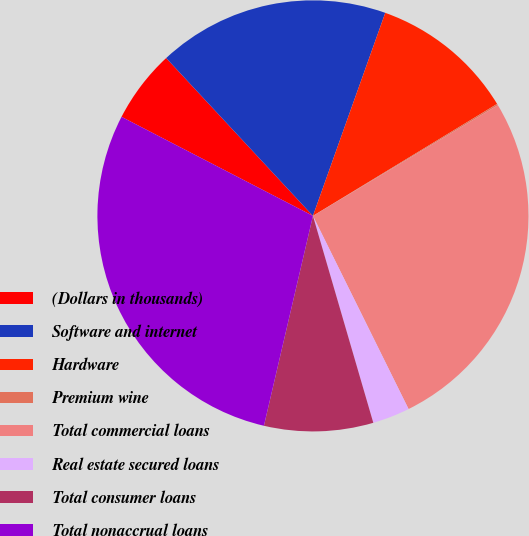Convert chart. <chart><loc_0><loc_0><loc_500><loc_500><pie_chart><fcel>(Dollars in thousands)<fcel>Software and internet<fcel>Hardware<fcel>Premium wine<fcel>Total commercial loans<fcel>Real estate secured loans<fcel>Total consumer loans<fcel>Total nonaccrual loans<nl><fcel>5.48%<fcel>17.37%<fcel>10.86%<fcel>0.11%<fcel>26.27%<fcel>2.8%<fcel>8.17%<fcel>28.95%<nl></chart> 